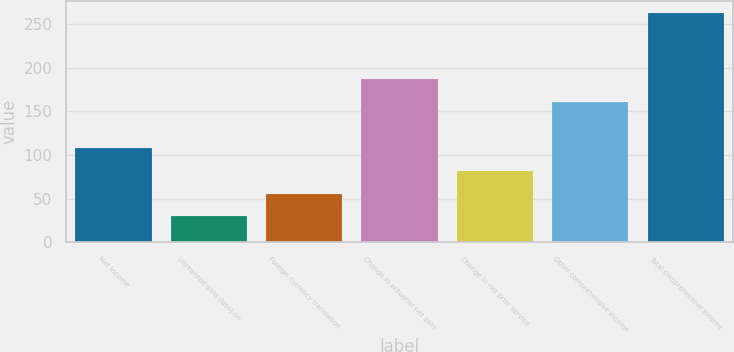Convert chart to OTSL. <chart><loc_0><loc_0><loc_500><loc_500><bar_chart><fcel>Net income<fcel>Unrealized gain (loss) on<fcel>Foreign currency translation<fcel>Change in actuarial net gain<fcel>Change in net prior service<fcel>Other comprehensive income<fcel>Total comprehensive income<nl><fcel>107.6<fcel>29.9<fcel>55.8<fcel>186.9<fcel>81.7<fcel>161<fcel>263<nl></chart> 